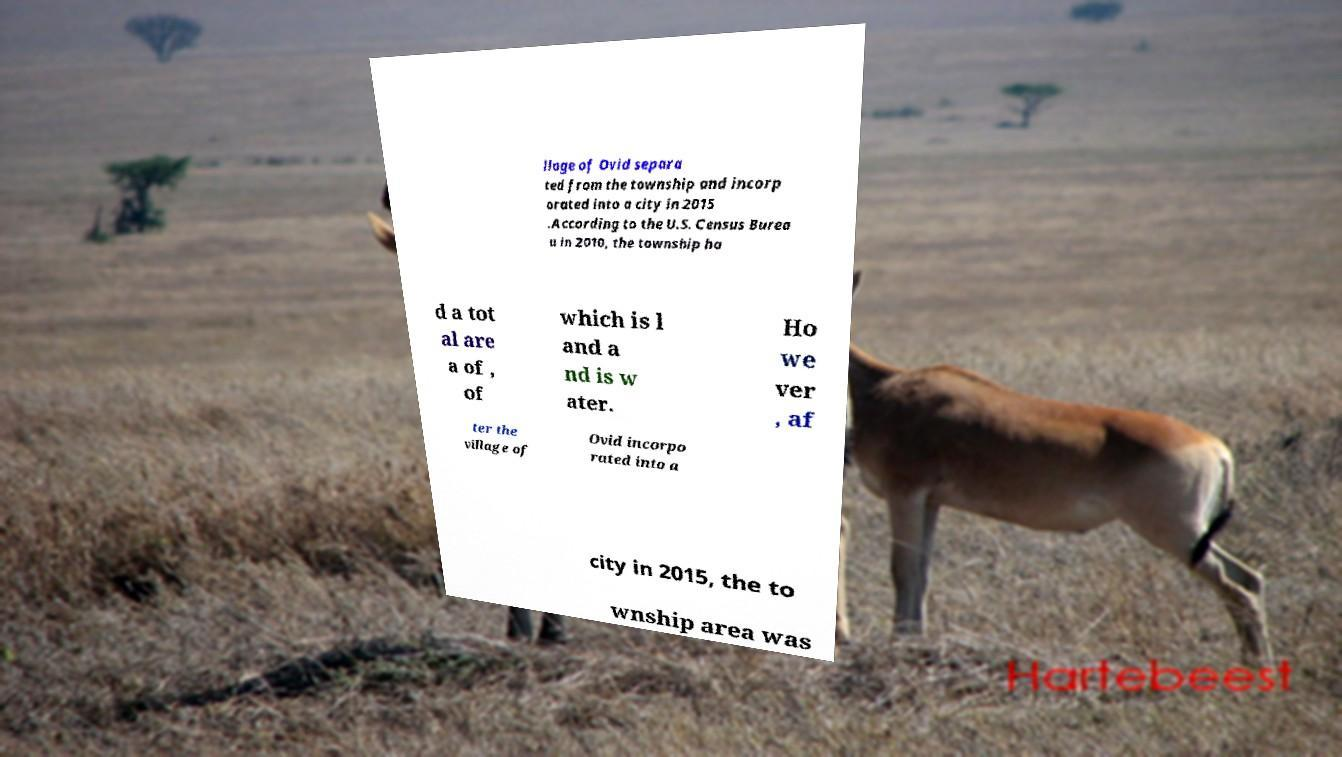Can you accurately transcribe the text from the provided image for me? llage of Ovid separa ted from the township and incorp orated into a city in 2015 .According to the U.S. Census Burea u in 2010, the township ha d a tot al are a of , of which is l and a nd is w ater. Ho we ver , af ter the village of Ovid incorpo rated into a city in 2015, the to wnship area was 